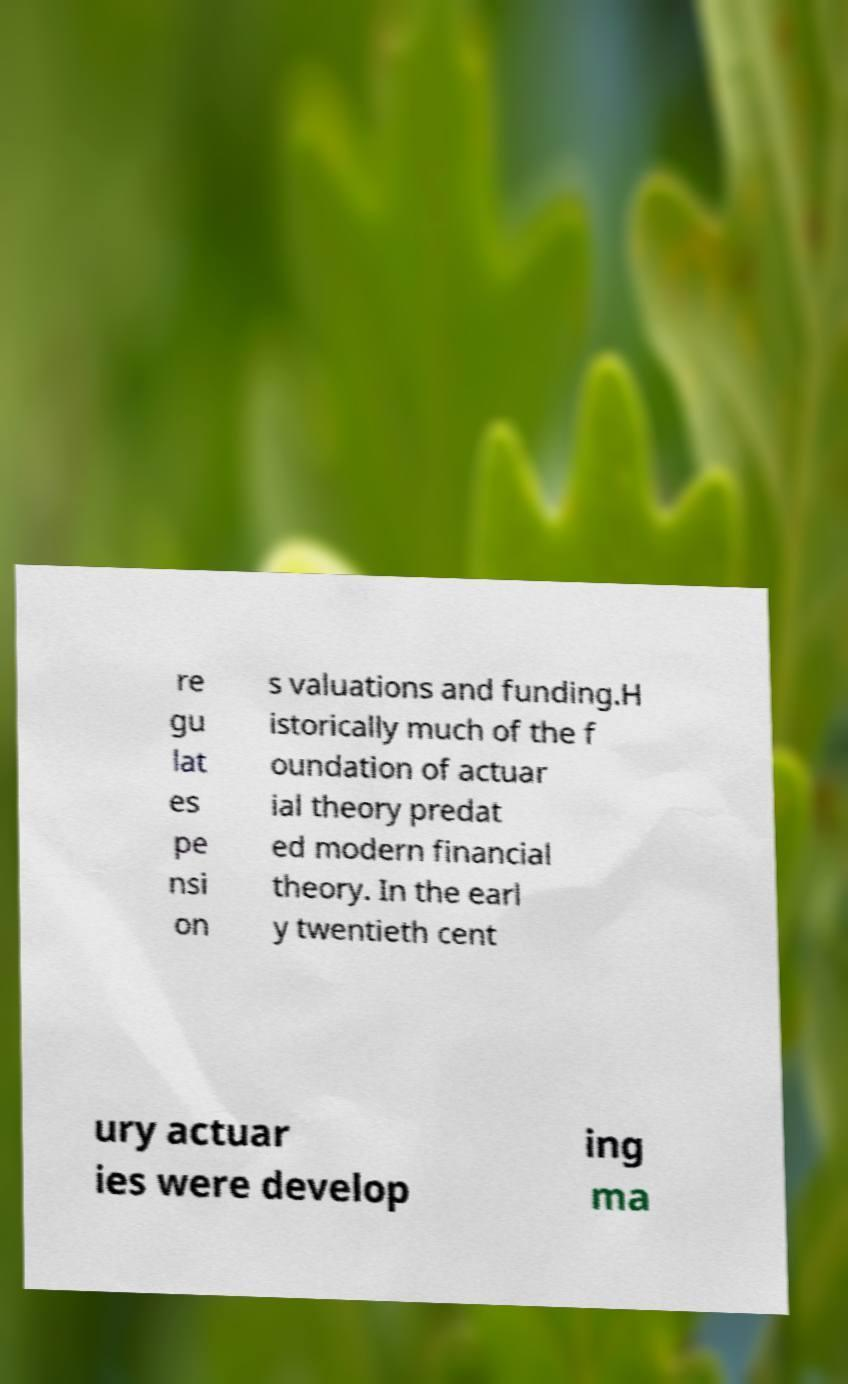Can you accurately transcribe the text from the provided image for me? re gu lat es pe nsi on s valuations and funding.H istorically much of the f oundation of actuar ial theory predat ed modern financial theory. In the earl y twentieth cent ury actuar ies were develop ing ma 